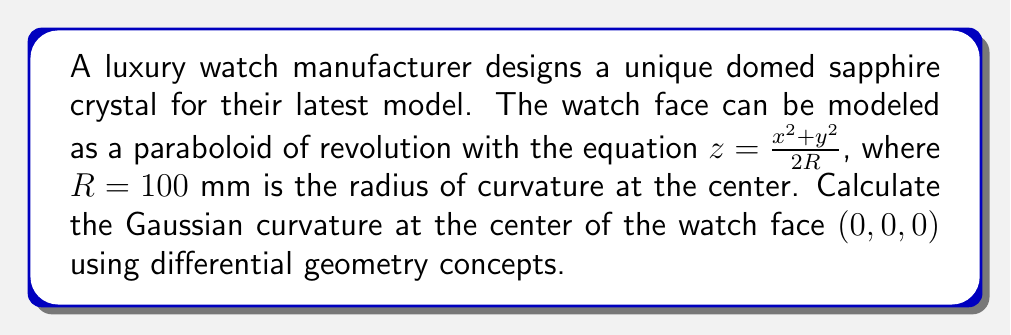Solve this math problem. To calculate the Gaussian curvature of the watch face, we'll follow these steps:

1) The watch face is modeled as a paraboloid of revolution with the equation:

   $$z = \frac{x^2 + y^2}{2R}$$

   where $R = 100$ mm.

2) To find the Gaussian curvature, we need to calculate the coefficients of the first and second fundamental forms.

3) First, let's calculate the partial derivatives:

   $$z_x = \frac{x}{R}, \quad z_y = \frac{y}{R}, \quad z_{xx} = \frac{1}{R}, \quad z_{yy} = \frac{1}{R}, \quad z_{xy} = 0$$

4) The coefficients of the first fundamental form are:

   $$E = 1 + z_x^2 = 1 + \frac{x^2}{R^2}$$
   $$F = z_x z_y = \frac{xy}{R^2}$$
   $$G = 1 + z_y^2 = 1 + \frac{y^2}{R^2}$$

5) The coefficients of the second fundamental form are:

   $$L = \frac{z_{xx}}{\sqrt{1 + z_x^2 + z_y^2}} = \frac{1/R}{\sqrt{1 + (x^2 + y^2)/R^2}}$$
   $$M = \frac{z_{xy}}{\sqrt{1 + z_x^2 + z_y^2}} = 0$$
   $$N = \frac{z_{yy}}{\sqrt{1 + z_x^2 + z_y^2}} = \frac{1/R}{\sqrt{1 + (x^2 + y^2)/R^2}}$$

6) The Gaussian curvature is given by:

   $$K = \frac{LN - M^2}{EG - F^2}$$

7) At the center point $(0, 0, 0)$, we have:

   $$E = G = 1, \quad F = 0$$
   $$L = N = \frac{1}{R}, \quad M = 0$$

8) Substituting these values into the Gaussian curvature formula:

   $$K = \frac{(1/R)(1/R) - 0^2}{(1)(1) - 0^2} = \frac{1}{R^2}$$

9) Finally, substituting $R = 100$ mm:

   $$K = \frac{1}{(100 \text{ mm})^2} = 0.0001 \text{ mm}^{-2}$$
Answer: The Gaussian curvature at the center of the watch face is $K = 0.0001 \text{ mm}^{-2}$. 